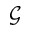<formula> <loc_0><loc_0><loc_500><loc_500>\mathcal { G }</formula> 